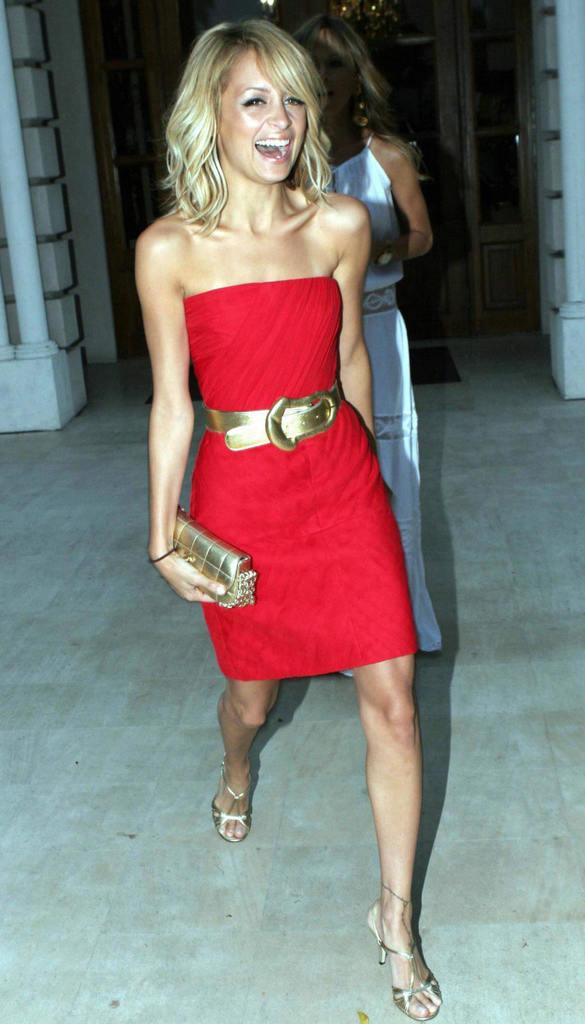How many women are in the image? There are two women in the image. What are the women doing in the image? The women are standing on the ground. What is one of the women holding? One of the women is holding a bag. What can be seen in the background of the image? There is a building in the background of the image. What feature of the building is mentioned? The building has doors. What type of sticks are the women using to grip the building in the image? There are no sticks or gripping actions present in the image. 